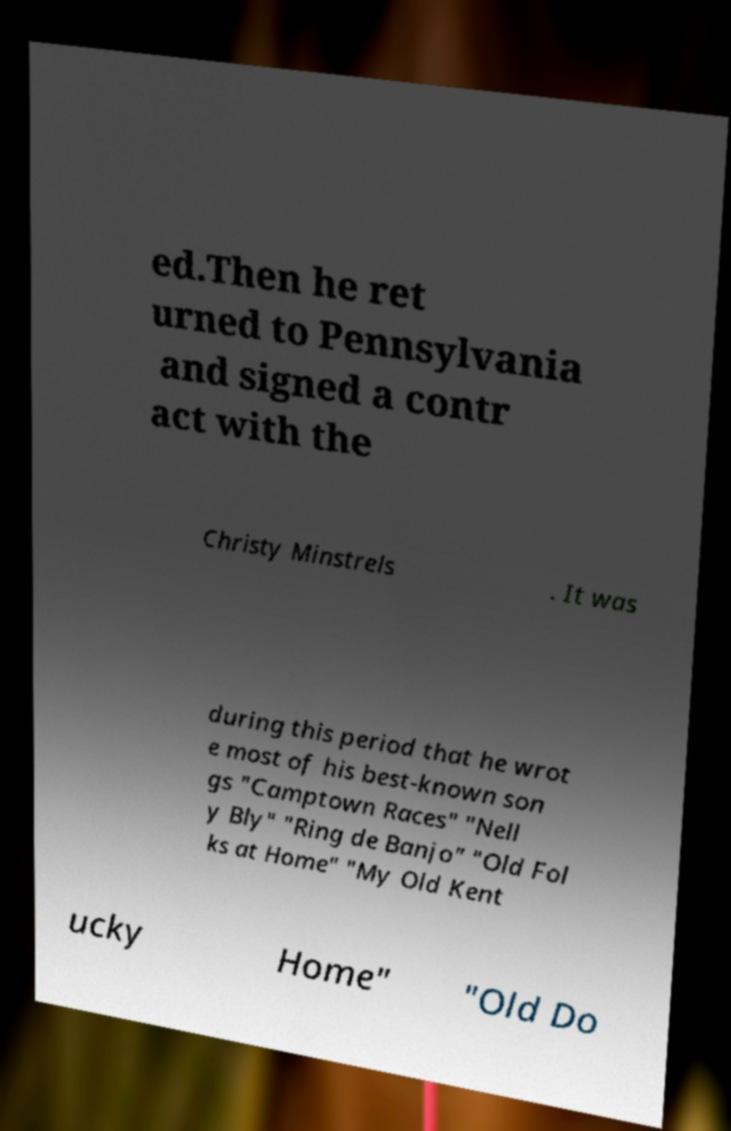Could you assist in decoding the text presented in this image and type it out clearly? ed.Then he ret urned to Pennsylvania and signed a contr act with the Christy Minstrels . It was during this period that he wrot e most of his best-known son gs "Camptown Races" "Nell y Bly" "Ring de Banjo" "Old Fol ks at Home" "My Old Kent ucky Home" "Old Do 